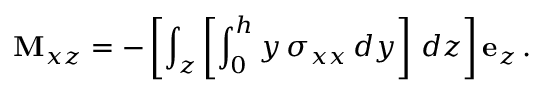<formula> <loc_0><loc_0><loc_500><loc_500>M _ { x z } = - \left [ \int _ { z } \left [ \int _ { 0 } ^ { h } y \, \sigma _ { x x } \, d y \right ] \, d z \right ] e _ { z } \, .</formula> 